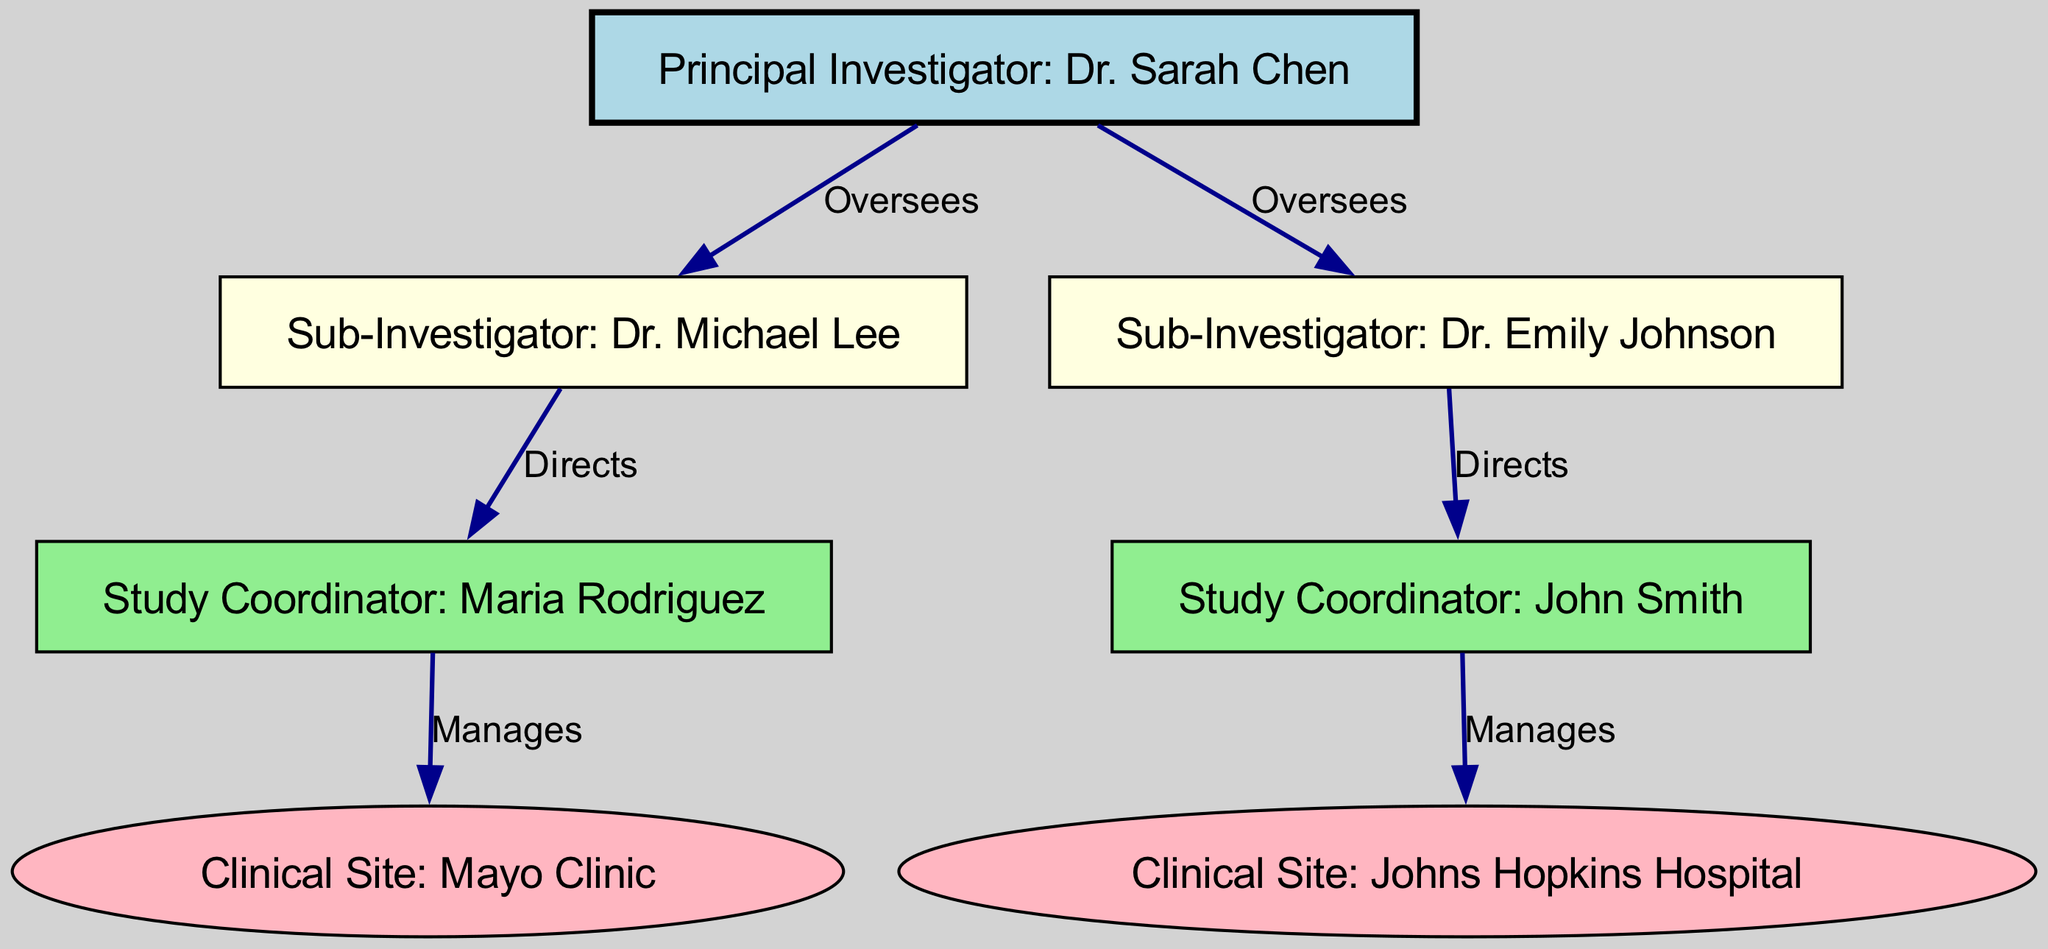What is the name of the Principal Investigator? The diagram directly labels the node for the Principal Investigator as "Dr. Sarah Chen."
Answer: Dr. Sarah Chen How many Sub-Investigators are there? By examining the nodes, I find two nodes labeled "Sub-Investigator: Dr. Michael Lee" and "Sub-Investigator: Dr. Emily Johnson," indicating there are two.
Answer: 2 Which Study Coordinator manages the Mayo Clinic? Looking at the edges, the edge from "Study Coordinator: Maria Rodriguez" points to "Clinical Site: Mayo Clinic," indicating she manages that site.
Answer: Maria Rodriguez What is the relationship between Dr. Sarah Chen and Dr. Michael Lee? The edge labeled "Oversees" connects "Principal Investigator: Dr. Sarah Chen" to "Sub-Investigator: Dr. Michael Lee," indicating that Dr. Chen oversees Dr. Lee's work.
Answer: Oversees Which Clinical Site is managed by John Smith? The diagram shows an edge from "Study Coordinator: John Smith" to "Clinical Site: Johns Hopkins Hospital," confirming that he manages this site.
Answer: Johns Hopkins Hospital How many edges are in this directed graph? By counting the relationships represented by the edges, I find there are six edges connecting the nodes.
Answer: 6 What is the hierarchical position of Maria Rodriguez in relation to Dr. Sarah Chen? The edge from "Principal Investigator: Dr. Sarah Chen" to "Sub-Investigator: Dr. Michael Lee" and then "Study Coordinator: Maria Rodriguez" indicates that she is at a lower level, managed by the Sub-Investigator.
Answer: Lower level Who directs the Study Coordinator that manages the Mayo Clinic? The edge labeled "Directs" connects "Sub-Investigator: Dr. Michael Lee" to "Study Coordinator: Maria Rodriguez," indicating that he directs her.
Answer: Dr. Michael Lee Which role has the highest authority in this clinical trial structure? The "Principal Investigator: Dr. Sarah Chen" is at the top of the hierarchy, overseeing the Sub-Investigators and Study Coordinators, giving her the highest authority.
Answer: Principal Investigator 